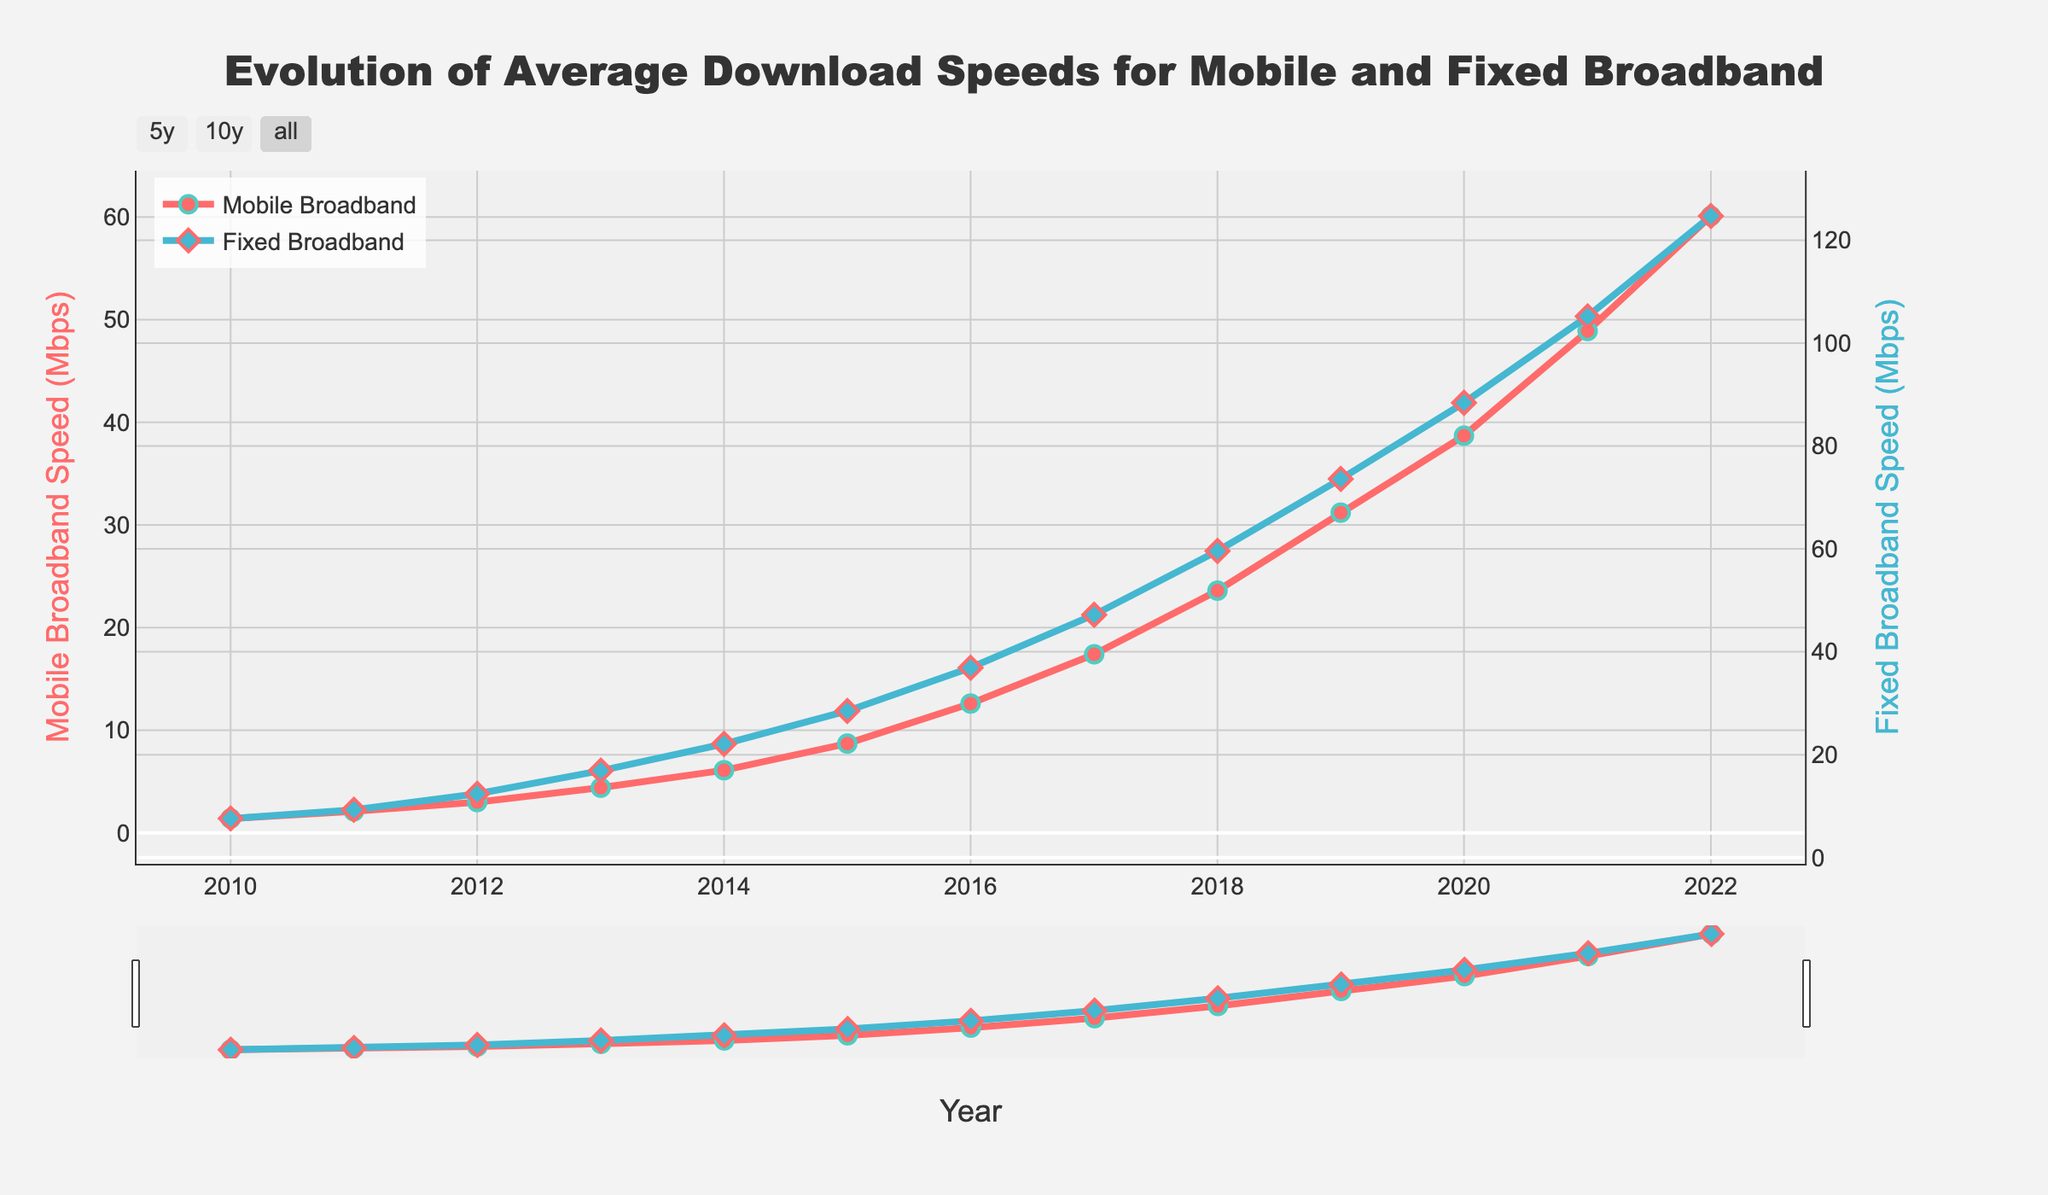What is the overall trend of mobile broadband speeds from 2010 to 2022? By looking at the line for mobile broadband speeds, it shows a consistent upward trend, indicating that mobile broadband speeds have increased over the years.
Answer: Increasing Which year shows the largest increase in mobile broadband speed compared to the previous year? By observing the year-to-year changes on the mobile broadband line, the largest increase occurs between 2021 (48.9 Mbps) and 2022 (60.1 Mbps), which is 11.2 Mbps.
Answer: 2021 to 2022 How does the fixed broadband speed in 2018 compare to the mobile broadband speed in the same year? Looking at the data points for both lines in 2018, fixed broadband speed is 59.6 Mbps, and mobile broadband speed is 23.6 Mbps. The fixed broadband speed is higher.
Answer: Higher What can be said about the speed difference between mobile and fixed broadband in 2020? By identifying the speeds for both broadband types in 2020, mobile is 38.7 Mbps and fixed is 88.4 Mbps. The difference is 88.4 Mbps - 38.7 Mbps = 49.7 Mbps, with fixed broadband being faster.
Answer: Fixed broadband is faster by 49.7 Mbps How much did the fixed broadband speed increase from 2010 to 2022? The fixed broadband speed in 2010 was 7.6 Mbps and in 2022 it was 124.7 Mbps. The increase is 124.7 Mbps - 7.6 Mbps = 117.1 Mbps.
Answer: 117.1 Mbps What is the average speed of mobile broadband over the entire period? Adding up the mobile broadband speeds from 2010 to 2022 and dividing by the number of years (13): (1.4 + 2.1 + 3.0 + 4.4 + 6.1 + 8.7 + 12.6 + 17.4 + 23.6 + 31.2 + 38.7 + 48.9 + 60.1) / 13 ≈ 19.27 Mbps.
Answer: ≈ 19.27 Mbps In which year did the mobile broadband speed first surpass 10 Mbps? By following the mobile broadband speed trend, the first year it surpasses 10 Mbps is 2016 with 12.6 Mbps.
Answer: 2016 How did the speed of fixed broadband change from 2019 to 2021? Observing the fixed broadband line, in 2019 the speed was 73.6 Mbps and in 2021 it was 105.2 Mbps. The change in speed is 105.2 Mbps - 73.6 Mbps = 31.6 Mbps increase.
Answer: Increased by 31.6 Mbps Compare the growth rates of mobile and fixed broadband from 2015 to 2020. For mobile broadband: From 8.7 Mbps to 38.7 Mbps, an increase of 38.7 - 8.7 = 30 Mbps. For fixed broadband: From 28.5 Mbps to 88.4 Mbps, an increase of 88.4 - 28.5 = 59.9 Mbps. The fixed broadband had a higher growth rate over this period.
Answer: Fixed broadband had higher growth Which broadband type had higher speeds in 2013, and by how much? The speeds in 2013 are 4.4 Mbps for mobile and 16.9 Mbps for fixed. Fixed broadband has higher speeds by 16.9 Mbps - 4.4 Mbps = 12.5 Mbps.
Answer: Fixed broadband by 12.5 Mbps 